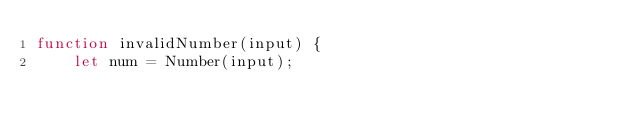Convert code to text. <code><loc_0><loc_0><loc_500><loc_500><_JavaScript_>function invalidNumber(input) {
    let num = Number(input);
</code> 